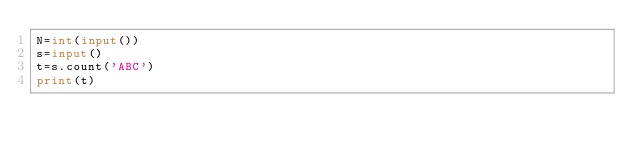Convert code to text. <code><loc_0><loc_0><loc_500><loc_500><_Python_>N=int(input())
s=input()
t=s.count('ABC')
print(t)</code> 